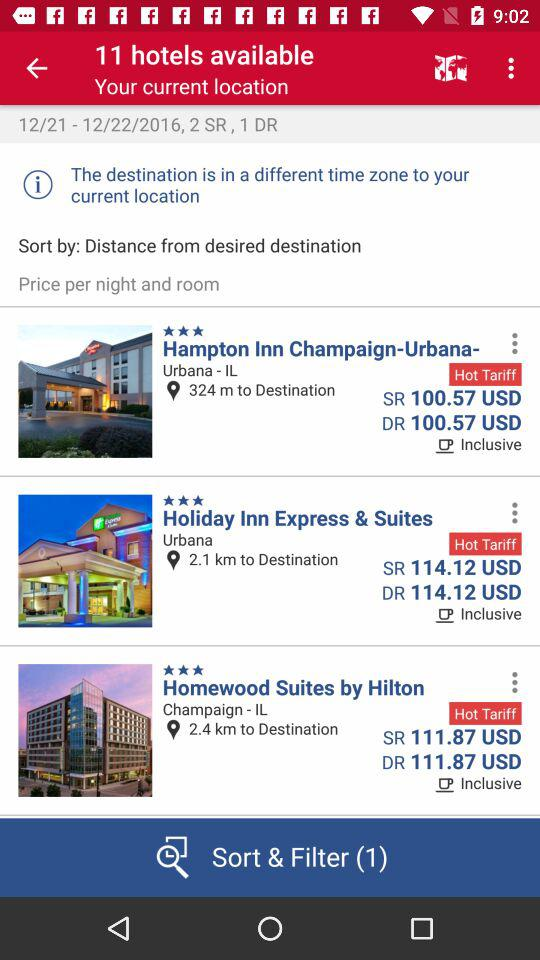How many hotels are available?
Answer the question using a single word or phrase. 11 